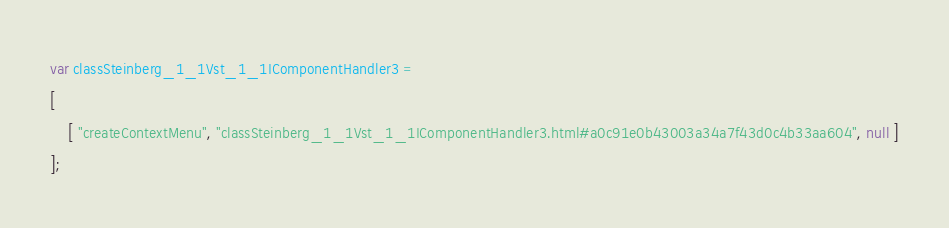<code> <loc_0><loc_0><loc_500><loc_500><_JavaScript_>var classSteinberg_1_1Vst_1_1IComponentHandler3 =
[
    [ "createContextMenu", "classSteinberg_1_1Vst_1_1IComponentHandler3.html#a0c91e0b43003a34a7f43d0c4b33aa604", null ]
];</code> 